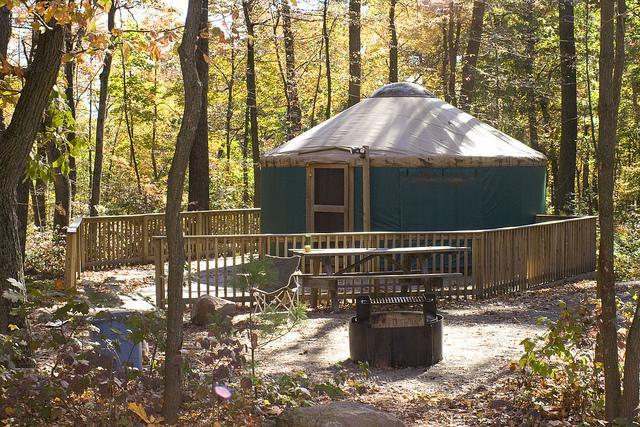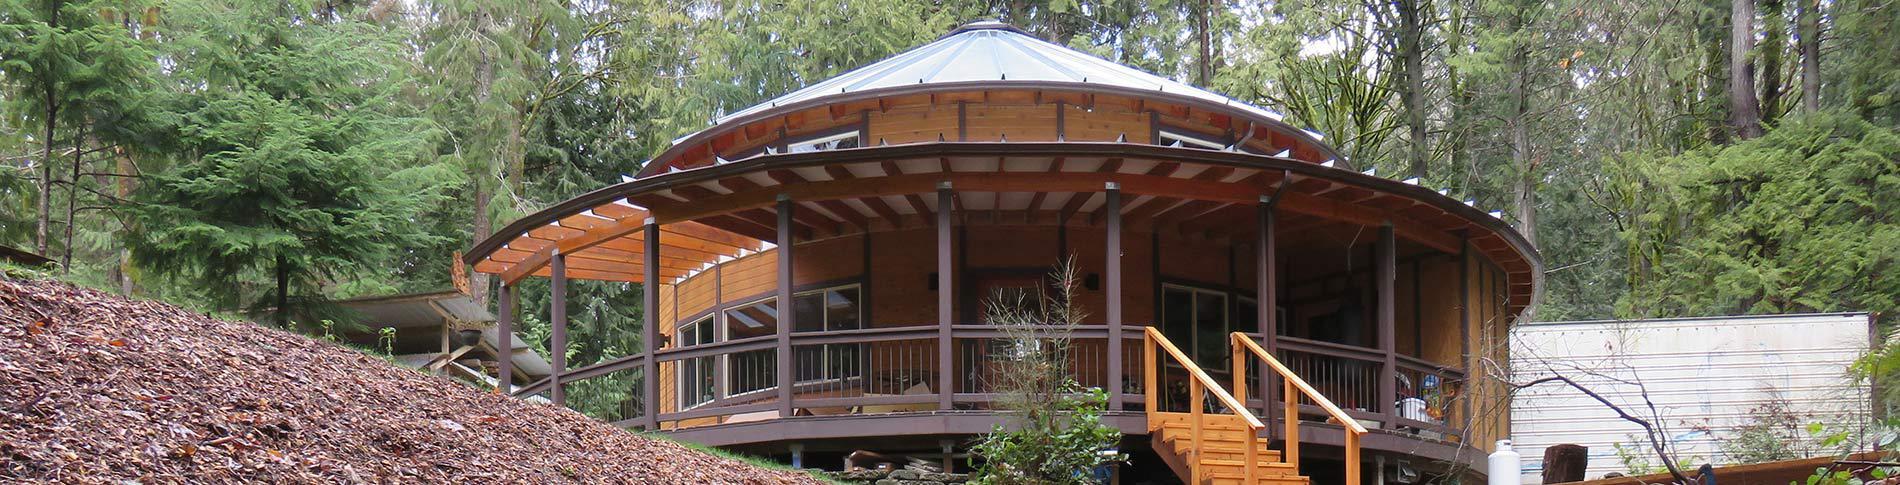The first image is the image on the left, the second image is the image on the right. Evaluate the accuracy of this statement regarding the images: "At least one image you can see inside of the house.". Is it true? Answer yes or no. No. 